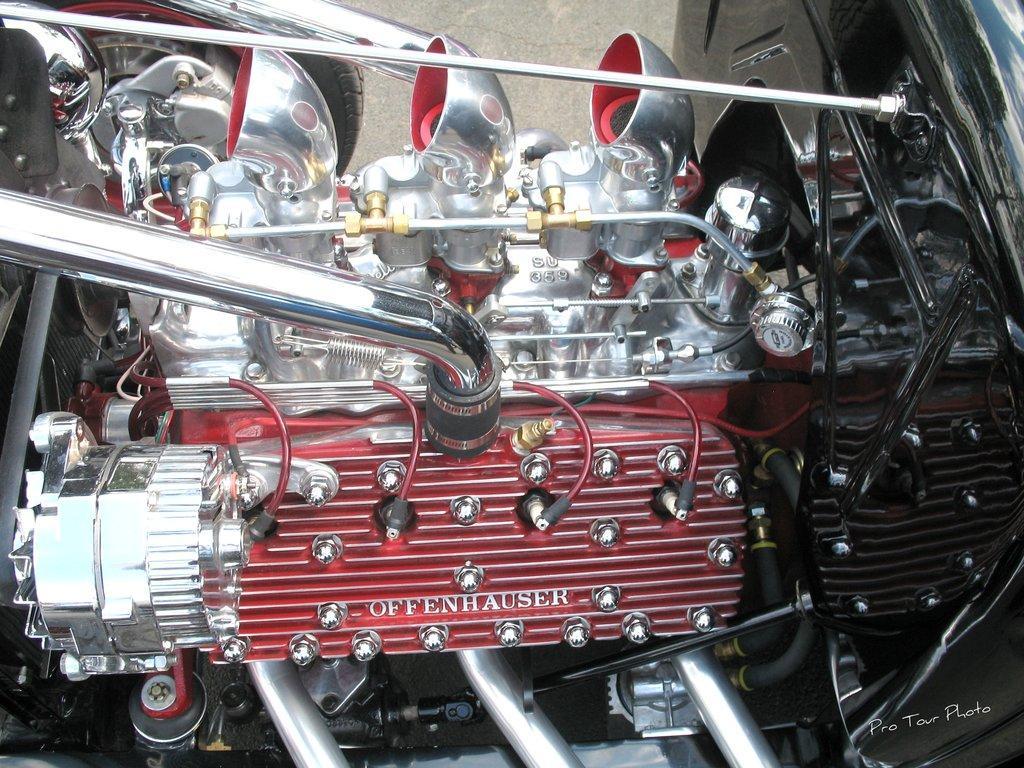Please provide a concise description of this image. In this image, we can see front side of a vehicle. In the background, we can see a wall. 